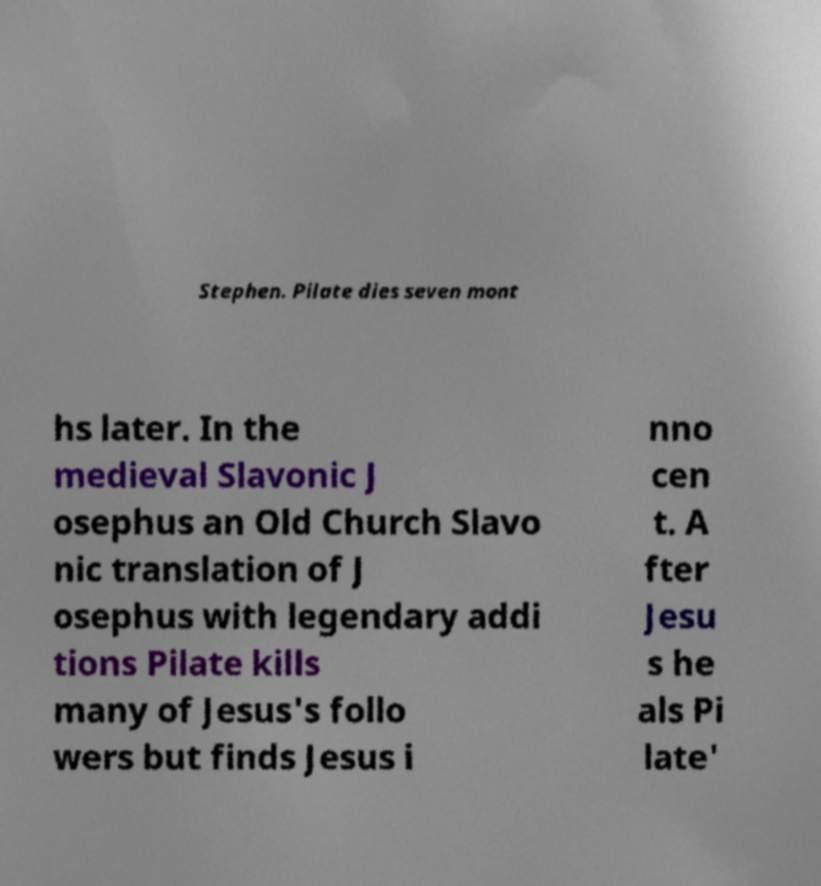For documentation purposes, I need the text within this image transcribed. Could you provide that? Stephen. Pilate dies seven mont hs later. In the medieval Slavonic J osephus an Old Church Slavo nic translation of J osephus with legendary addi tions Pilate kills many of Jesus's follo wers but finds Jesus i nno cen t. A fter Jesu s he als Pi late' 